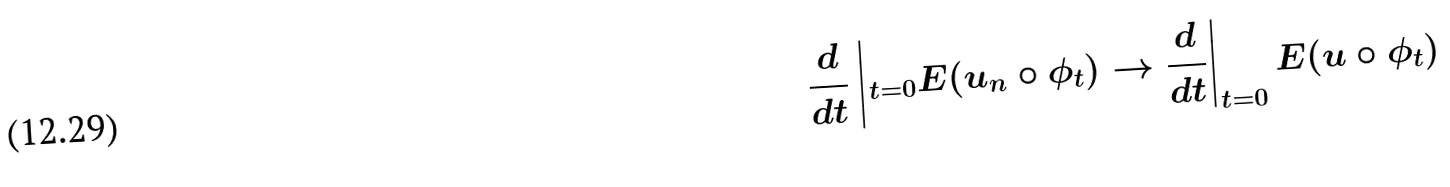Convert formula to latex. <formula><loc_0><loc_0><loc_500><loc_500>\frac { d } { d t } \left | _ { t = 0 } E ( u _ { n } \circ \phi _ { t } ) \to \frac { d } { d t } \right | _ { t = 0 } E ( u \circ \phi _ { t } )</formula> 